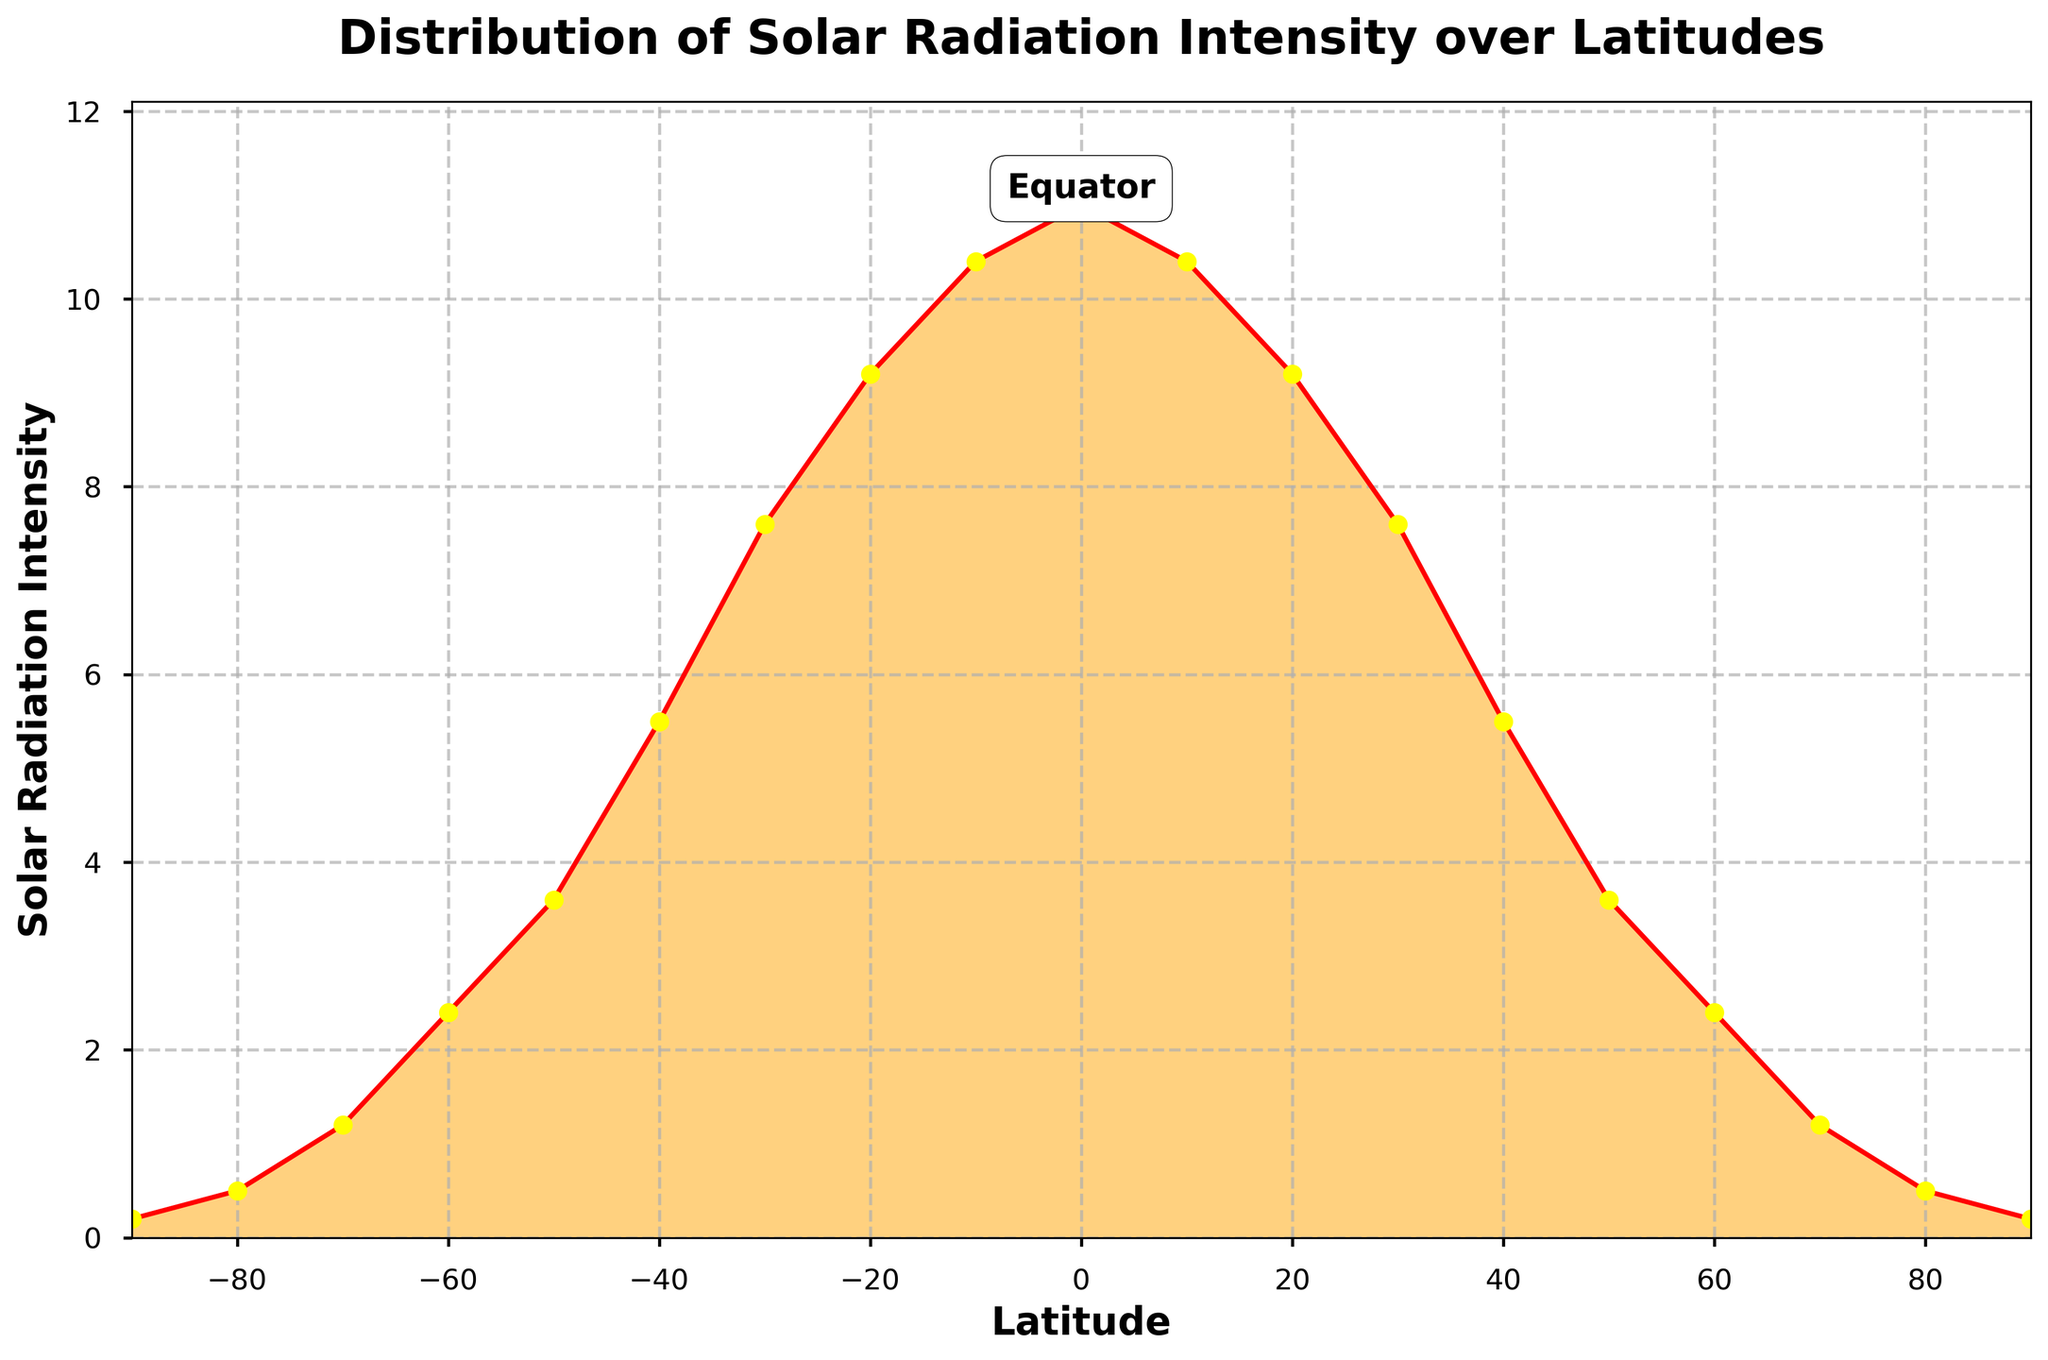What is the title of the plot? The title of the plot is located at the top and is labeled in larger, bold font.
Answer: Distribution of Solar Radiation Intensity over Latitudes What is the Solar Radiation Intensity at the Equator (Latitude 0)? Identify the data point corresponding to latitude 0 on the x-axis, then follow it up to the y-axis to find the Solar Radiation Intensity.
Answer: 11.0 What are the maximum and minimum Solar Radiation Intensities shown in the plot? The maximum value is the highest point on the density plot, and the minimum value is the lowest.
Answer: Maximum is 11.0, Minimum is 0.2 How does the Solar Radiation Intensity change as you move from the poles to the Equator? Observe the trend in the density plot from latitudes -90 to 0 and from 0 to 90. The plot shows an increase in intensity from the poles to the Equator.
Answer: It increases Which latitude has the highest Solar Radiation Intensity and what is the value? Look for the peak of the plot, which indicates the highest intensity. Identify the latitude at this peak and its corresponding y-axis value.
Answer: Latitude 0, value 11.0 At what latitudes is the Solar Radiation Intensity 10.4? Locate the points on the y-axis where the Solar Radiation Intensity is 10.4 and match those with their corresponding x-axis (latitude) values.
Answer: Latitudes 10 and -10 Is the distribution of Solar Radiation Intensity symmetric about the Equator? Analyze the shape of the plot on either side of the Equator (latitude 0) to see if it is mirrored.
Answer: Yes What is the Solar Radiation Intensity at Latitude 30 and Latitude -30, and how do they compare? Find the data points at latitudes 30 and -30 on the x-axis, then read their corresponding values on the y-axis. Compare these values.
Answer: Both are 7.6, they are equal How does the plot indicate that the equatorial region receives the maximum Solar Radiation Intensity? Look at the annotations and the peak in the plot that corresponds to the Equator.
Answer: The peak at Latitude 0 and the "Equator" annotation indicate this 